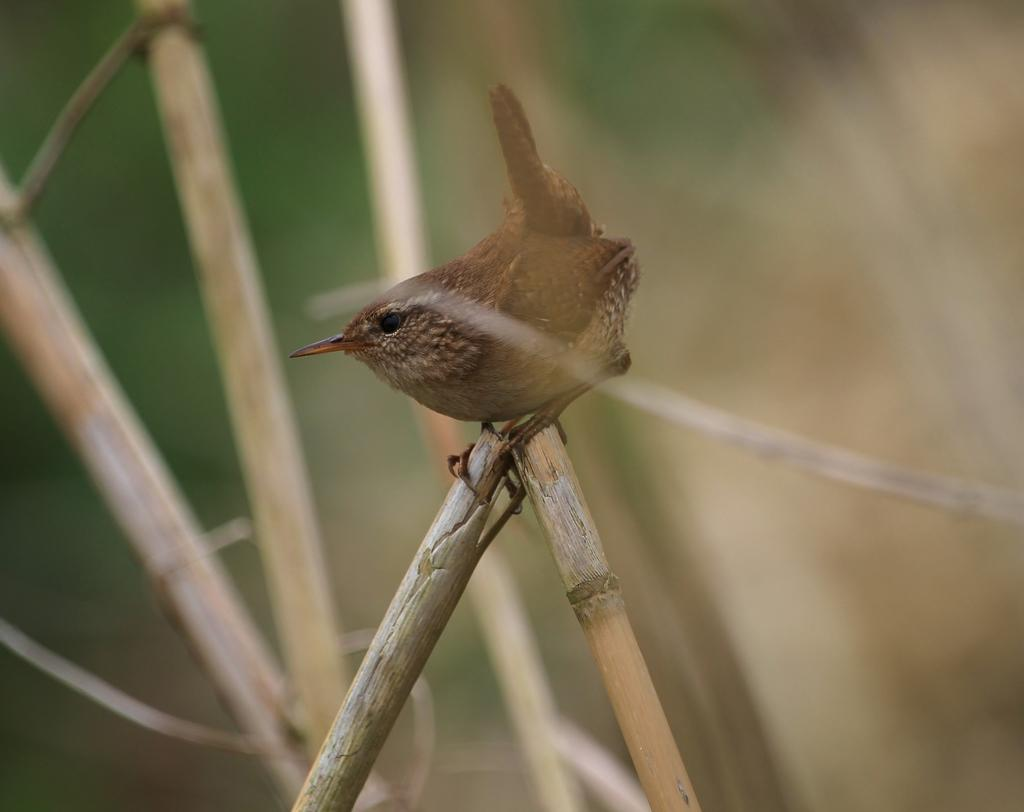What type of animal can be seen in the image? There is a bird in the image. What color is the bird? The bird is brown in color. What is the bird sitting on in the image? The bird is on wooden sticks. Are there any other wooden sticks visible in the image? Yes, there are additional wooden sticks in the image. How would you describe the background of the image? The background of the image is blurred. How does the bird cover its nest in the image? The image does not show the bird covering a nest, so we cannot answer this question. 